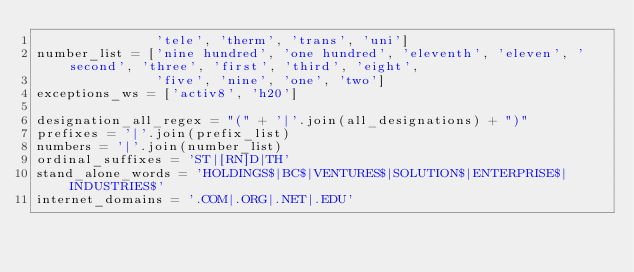Convert code to text. <code><loc_0><loc_0><loc_500><loc_500><_Python_>               'tele', 'therm', 'trans', 'uni']
number_list = ['nine hundred', 'one hundred', 'eleventh', 'eleven', 'second', 'three', 'first', 'third', 'eight',
               'five', 'nine', 'one', 'two']
exceptions_ws = ['activ8', 'h20']

designation_all_regex = "(" + '|'.join(all_designations) + ")"
prefixes = '|'.join(prefix_list)
numbers = '|'.join(number_list)
ordinal_suffixes = 'ST|[RN]D|TH'
stand_alone_words = 'HOLDINGS$|BC$|VENTURES$|SOLUTION$|ENTERPRISE$|INDUSTRIES$'
internet_domains = '.COM|.ORG|.NET|.EDU'</code> 